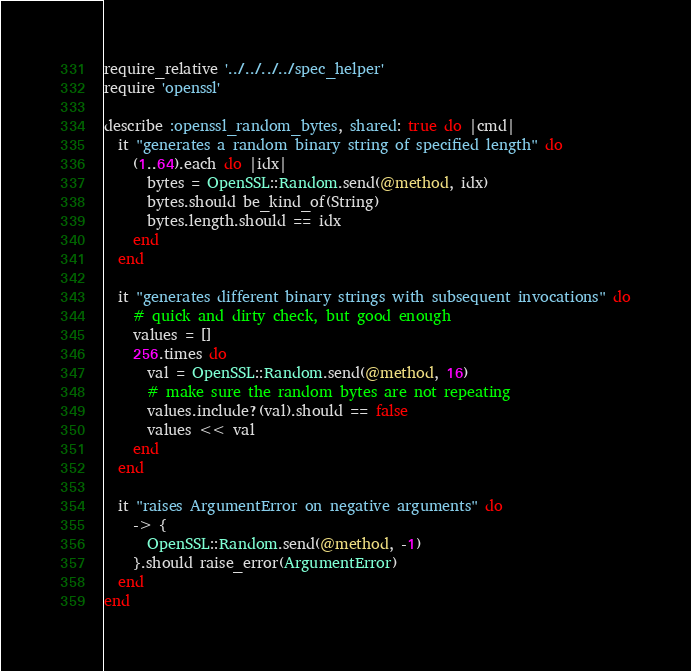<code> <loc_0><loc_0><loc_500><loc_500><_Ruby_>require_relative '../../../../spec_helper'
require 'openssl'

describe :openssl_random_bytes, shared: true do |cmd|
  it "generates a random binary string of specified length" do
    (1..64).each do |idx|
      bytes = OpenSSL::Random.send(@method, idx)
      bytes.should be_kind_of(String)
      bytes.length.should == idx
    end
  end

  it "generates different binary strings with subsequent invocations" do
    # quick and dirty check, but good enough
    values = []
    256.times do
      val = OpenSSL::Random.send(@method, 16)
      # make sure the random bytes are not repeating
      values.include?(val).should == false
      values << val
    end
  end

  it "raises ArgumentError on negative arguments" do
    -> {
      OpenSSL::Random.send(@method, -1)
    }.should raise_error(ArgumentError)
  end
end
</code> 